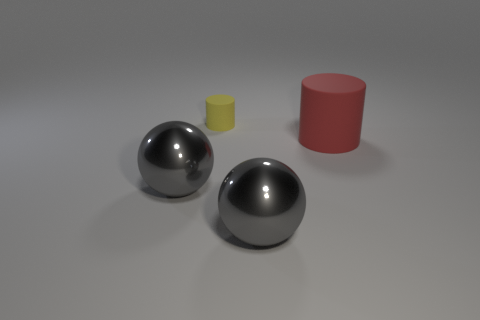Add 2 small yellow matte cylinders. How many objects exist? 6 Add 2 yellow cylinders. How many yellow cylinders are left? 3 Add 4 small yellow matte objects. How many small yellow matte objects exist? 5 Subtract 0 gray cylinders. How many objects are left? 4 Subtract all shiny things. Subtract all yellow rubber things. How many objects are left? 1 